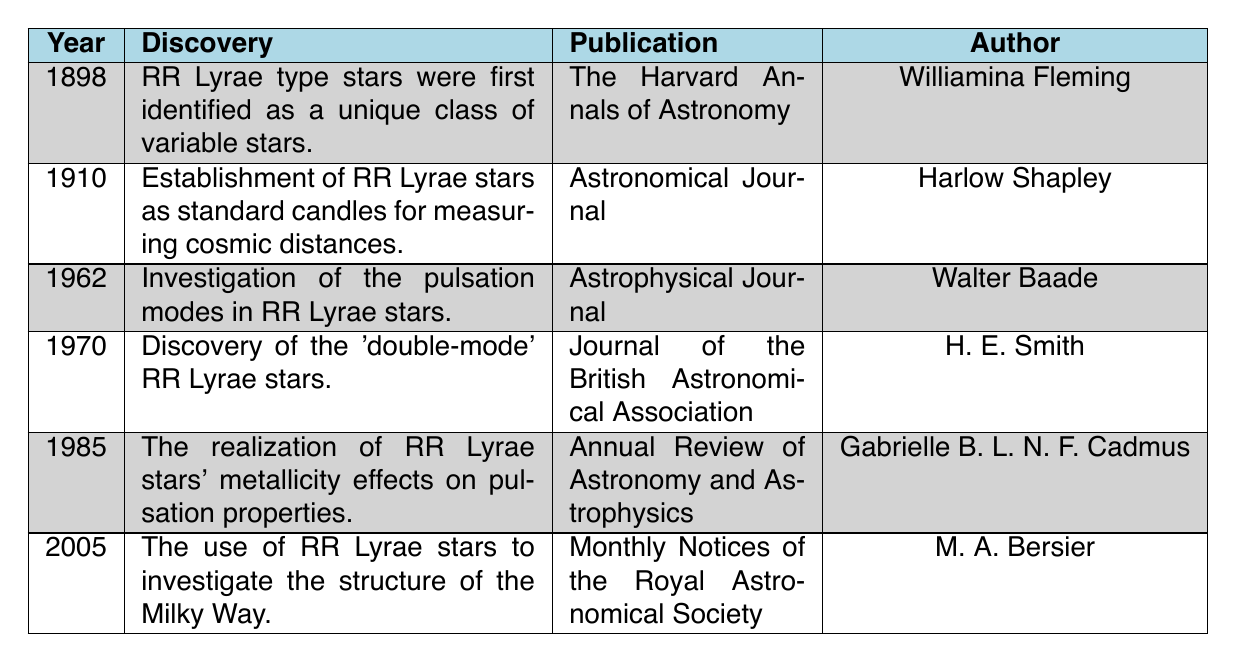What year were RR Lyrae type stars first identified? The table lists the year of discovery for RR Lyrae type stars as 1898 in the first row. Therefore, the answer is based directly on this entry.
Answer: 1898 Who authored the publication regarding the establishment of RR Lyrae stars as standard candles? By locating the row with the discovery regarding standard candles (1910), we find the author listed is Harlow Shapley.
Answer: Harlow Shapley How many discoveries about RR Lyrae stars are documented in the table? We can count the rows in the table, which total six distinct discoveries, each represented by a unique year.
Answer: 6 Was the investigation of pulsation modes conducted before or after 1970? The entry for the investigation of pulsation modes is noted in 1962, which is before the year 1970 listed in the table. Thus, this discovery comes prior to the year 1970.
Answer: Before What is the average year of discovery from the data provided? To find the average year, we add all the years: (1898 + 1910 + 1962 + 1970 + 1985 + 2005) = 11630. Dividing by the number of discoveries (6) gives us an average year of 1938.33, which can be rounded to 1938.
Answer: 1938 Did any of the discoveries occur in the 1980s? There is one entry from the year 1985 about the realization of metallicity effects on pulsation properties, confirming a discovery occurred in the 1980s.
Answer: Yes Which author contributed to the publication discussing the double-mode RR Lyrae stars? By locating the year 1970 in the table, we see that the author for the double-mode discovery is H. E. Smith.
Answer: H. E. Smith What was the last year noted for a discovery related to RR Lyrae stars? The table's latest entry reflects the year of discovery as 2005, which marks the last documented discovery related to RR Lyrae stars in the time frame represented.
Answer: 2005 